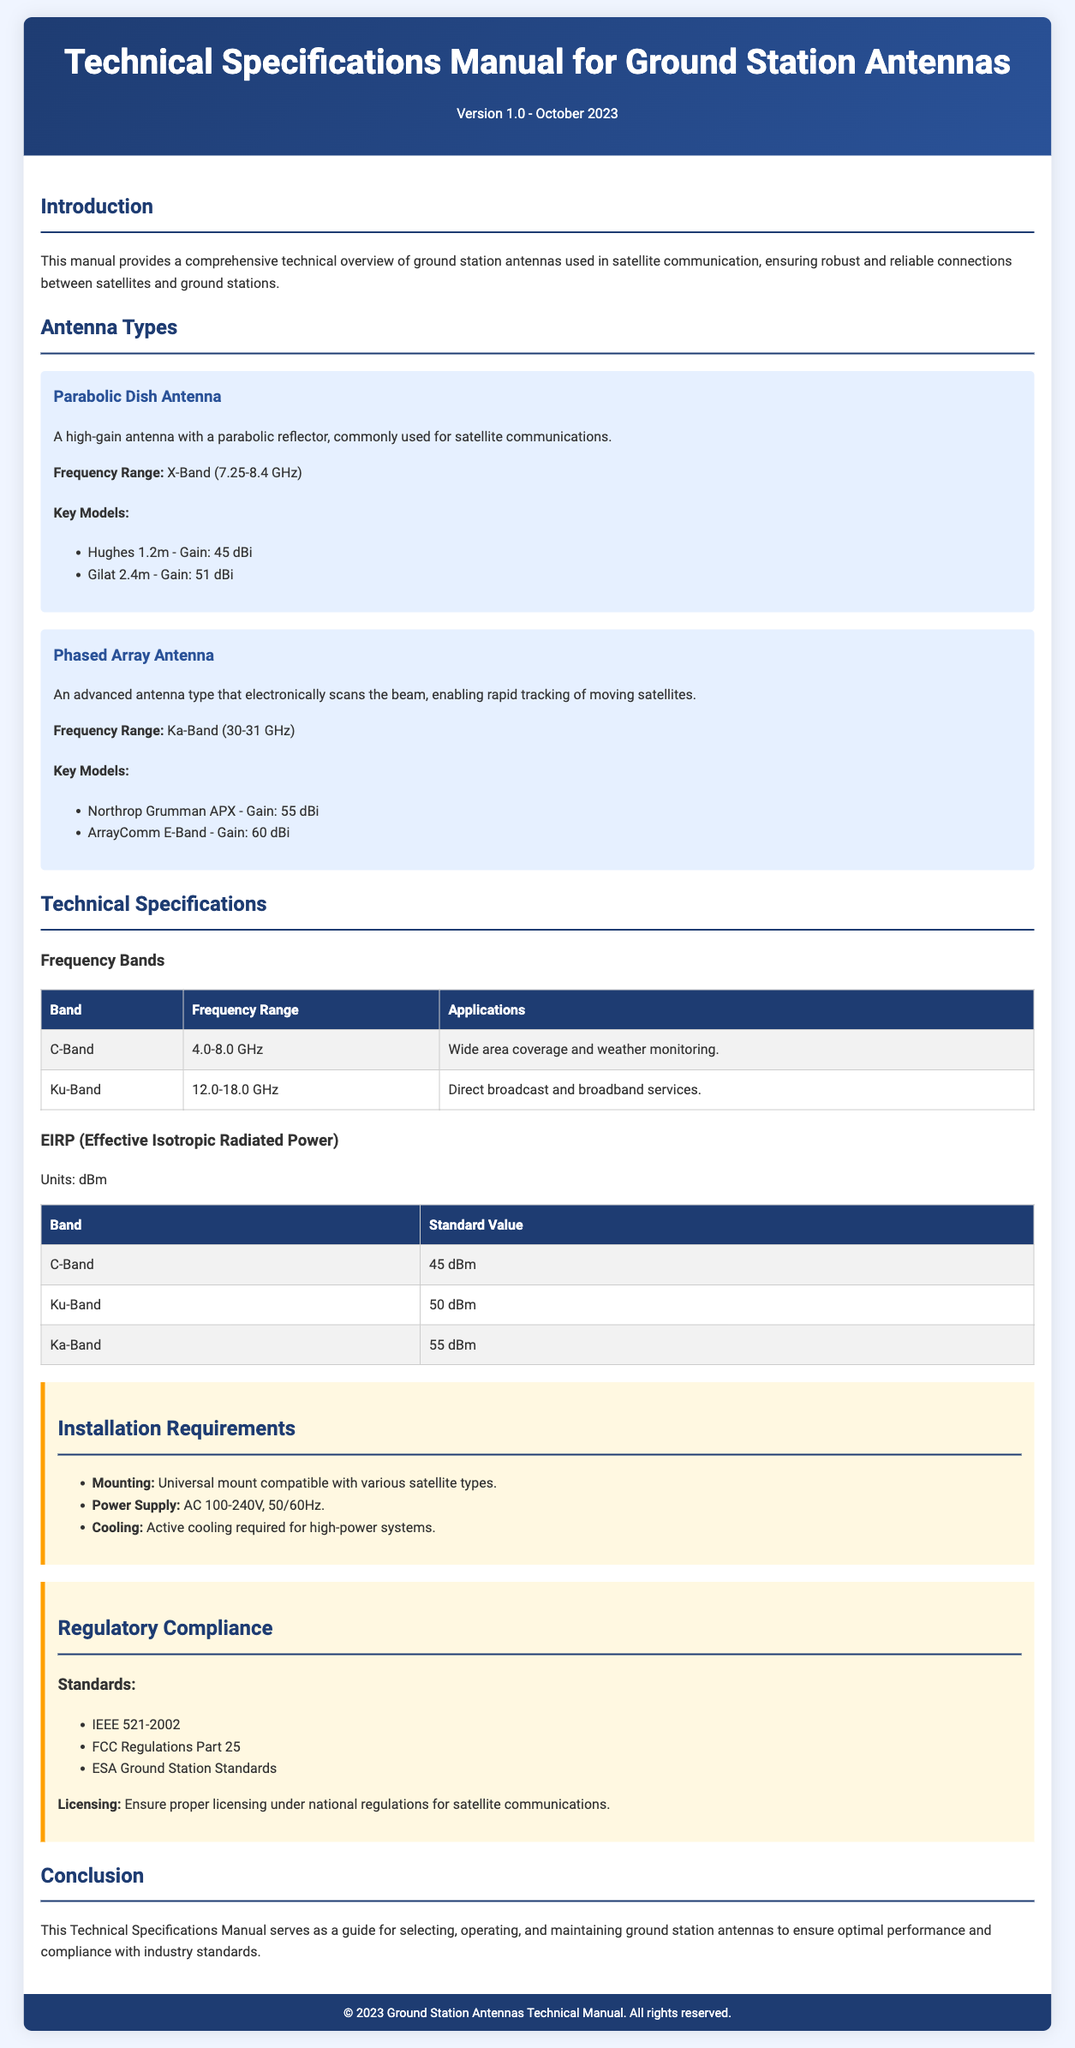What is the frequency range for X-Band antennas? The frequency range for X-Band antennas is specified in the document as 7.25-8.4 GHz.
Answer: 7.25-8.4 GHz What model has a gain of 55 dBi in the Ka-Band? The model that has a gain of 55 dBi in the Ka-Band is the Northrop Grumman APX.
Answer: Northrop Grumman APX What is the EIRP standard value for Ku-Band? The EIRP standard value for Ku-Band is provided in the document as 50 dBm.
Answer: 50 dBm How many antenna types are discussed in the document? There are two antenna types discussed in the document: Parabolic Dish Antenna and Phased Array Antenna.
Answer: Two What is the primary cooling requirement for high-power systems? The primary cooling requirement for high-power systems is mentioned as active cooling.
Answer: Active cooling What standard mandates compliance for satellite communications? The standard that mandates compliance for satellite communications is IEEE 521-2002.
Answer: IEEE 521-2002 What is the power supply requirement stated in the installation section? The power supply requirement stated is AC 100-240V, 50/60Hz.
Answer: AC 100-240V, 50/60Hz What is the document's version and date? The version and date mentioned in the document are Version 1.0 - October 2023.
Answer: Version 1.0 - October 2023 What is the application of C-Band antennas? The application for C-Band antennas is wide area coverage and weather monitoring.
Answer: Wide area coverage and weather monitoring 